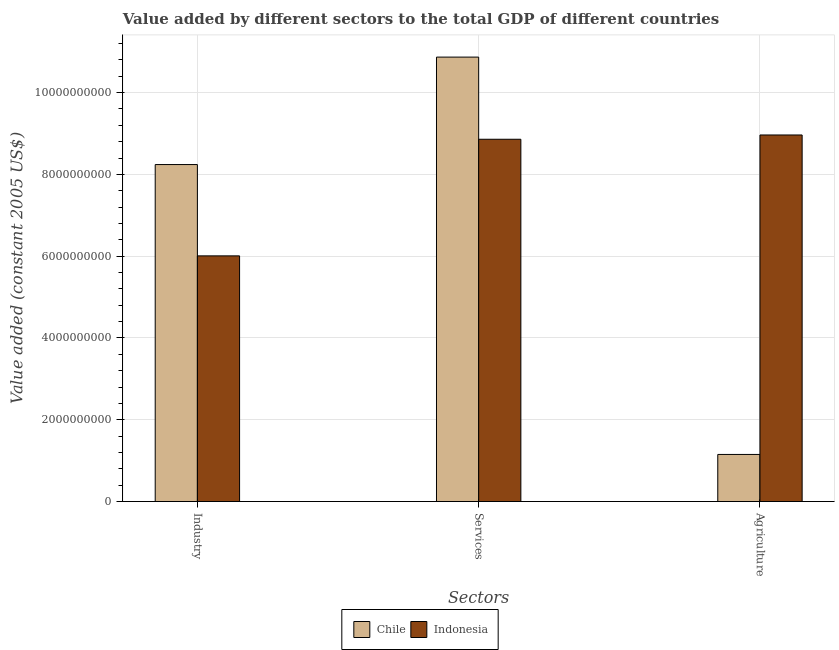How many different coloured bars are there?
Make the answer very short. 2. Are the number of bars per tick equal to the number of legend labels?
Ensure brevity in your answer.  Yes. Are the number of bars on each tick of the X-axis equal?
Provide a short and direct response. Yes. How many bars are there on the 1st tick from the left?
Your response must be concise. 2. How many bars are there on the 3rd tick from the right?
Your answer should be compact. 2. What is the label of the 2nd group of bars from the left?
Offer a very short reply. Services. What is the value added by agricultural sector in Indonesia?
Provide a succinct answer. 8.96e+09. Across all countries, what is the maximum value added by services?
Give a very brief answer. 1.09e+1. Across all countries, what is the minimum value added by agricultural sector?
Your response must be concise. 1.15e+09. In which country was the value added by industrial sector maximum?
Offer a terse response. Chile. In which country was the value added by services minimum?
Keep it short and to the point. Indonesia. What is the total value added by agricultural sector in the graph?
Provide a short and direct response. 1.01e+1. What is the difference between the value added by services in Chile and that in Indonesia?
Your answer should be compact. 2.01e+09. What is the difference between the value added by agricultural sector in Chile and the value added by services in Indonesia?
Give a very brief answer. -7.71e+09. What is the average value added by services per country?
Offer a terse response. 9.86e+09. What is the difference between the value added by agricultural sector and value added by industrial sector in Chile?
Give a very brief answer. -7.09e+09. What is the ratio of the value added by agricultural sector in Chile to that in Indonesia?
Ensure brevity in your answer.  0.13. Is the value added by services in Chile less than that in Indonesia?
Keep it short and to the point. No. Is the difference between the value added by agricultural sector in Indonesia and Chile greater than the difference between the value added by industrial sector in Indonesia and Chile?
Your answer should be compact. Yes. What is the difference between the highest and the second highest value added by industrial sector?
Provide a short and direct response. 2.23e+09. What is the difference between the highest and the lowest value added by services?
Offer a terse response. 2.01e+09. Is the sum of the value added by industrial sector in Chile and Indonesia greater than the maximum value added by services across all countries?
Provide a short and direct response. Yes. What does the 1st bar from the left in Agriculture represents?
Keep it short and to the point. Chile. How many bars are there?
Your answer should be compact. 6. Are all the bars in the graph horizontal?
Provide a succinct answer. No. How many countries are there in the graph?
Keep it short and to the point. 2. Does the graph contain grids?
Offer a very short reply. Yes. Where does the legend appear in the graph?
Your response must be concise. Bottom center. How are the legend labels stacked?
Offer a very short reply. Horizontal. What is the title of the graph?
Your answer should be very brief. Value added by different sectors to the total GDP of different countries. Does "Argentina" appear as one of the legend labels in the graph?
Your answer should be compact. No. What is the label or title of the X-axis?
Make the answer very short. Sectors. What is the label or title of the Y-axis?
Your answer should be very brief. Value added (constant 2005 US$). What is the Value added (constant 2005 US$) in Chile in Industry?
Make the answer very short. 8.24e+09. What is the Value added (constant 2005 US$) in Indonesia in Industry?
Ensure brevity in your answer.  6.01e+09. What is the Value added (constant 2005 US$) in Chile in Services?
Your answer should be very brief. 1.09e+1. What is the Value added (constant 2005 US$) in Indonesia in Services?
Offer a terse response. 8.86e+09. What is the Value added (constant 2005 US$) of Chile in Agriculture?
Your answer should be compact. 1.15e+09. What is the Value added (constant 2005 US$) of Indonesia in Agriculture?
Keep it short and to the point. 8.96e+09. Across all Sectors, what is the maximum Value added (constant 2005 US$) of Chile?
Provide a short and direct response. 1.09e+1. Across all Sectors, what is the maximum Value added (constant 2005 US$) of Indonesia?
Offer a very short reply. 8.96e+09. Across all Sectors, what is the minimum Value added (constant 2005 US$) of Chile?
Provide a succinct answer. 1.15e+09. Across all Sectors, what is the minimum Value added (constant 2005 US$) in Indonesia?
Your answer should be very brief. 6.01e+09. What is the total Value added (constant 2005 US$) of Chile in the graph?
Your response must be concise. 2.03e+1. What is the total Value added (constant 2005 US$) of Indonesia in the graph?
Offer a terse response. 2.38e+1. What is the difference between the Value added (constant 2005 US$) in Chile in Industry and that in Services?
Keep it short and to the point. -2.63e+09. What is the difference between the Value added (constant 2005 US$) of Indonesia in Industry and that in Services?
Your answer should be compact. -2.85e+09. What is the difference between the Value added (constant 2005 US$) in Chile in Industry and that in Agriculture?
Provide a succinct answer. 7.09e+09. What is the difference between the Value added (constant 2005 US$) of Indonesia in Industry and that in Agriculture?
Provide a short and direct response. -2.96e+09. What is the difference between the Value added (constant 2005 US$) of Chile in Services and that in Agriculture?
Keep it short and to the point. 9.72e+09. What is the difference between the Value added (constant 2005 US$) of Indonesia in Services and that in Agriculture?
Your response must be concise. -1.05e+08. What is the difference between the Value added (constant 2005 US$) in Chile in Industry and the Value added (constant 2005 US$) in Indonesia in Services?
Your answer should be compact. -6.19e+08. What is the difference between the Value added (constant 2005 US$) of Chile in Industry and the Value added (constant 2005 US$) of Indonesia in Agriculture?
Your answer should be compact. -7.23e+08. What is the difference between the Value added (constant 2005 US$) of Chile in Services and the Value added (constant 2005 US$) of Indonesia in Agriculture?
Make the answer very short. 1.90e+09. What is the average Value added (constant 2005 US$) in Chile per Sectors?
Make the answer very short. 6.75e+09. What is the average Value added (constant 2005 US$) in Indonesia per Sectors?
Offer a terse response. 7.94e+09. What is the difference between the Value added (constant 2005 US$) in Chile and Value added (constant 2005 US$) in Indonesia in Industry?
Provide a succinct answer. 2.23e+09. What is the difference between the Value added (constant 2005 US$) in Chile and Value added (constant 2005 US$) in Indonesia in Services?
Offer a terse response. 2.01e+09. What is the difference between the Value added (constant 2005 US$) of Chile and Value added (constant 2005 US$) of Indonesia in Agriculture?
Make the answer very short. -7.81e+09. What is the ratio of the Value added (constant 2005 US$) in Chile in Industry to that in Services?
Ensure brevity in your answer.  0.76. What is the ratio of the Value added (constant 2005 US$) of Indonesia in Industry to that in Services?
Give a very brief answer. 0.68. What is the ratio of the Value added (constant 2005 US$) of Chile in Industry to that in Agriculture?
Provide a succinct answer. 7.15. What is the ratio of the Value added (constant 2005 US$) in Indonesia in Industry to that in Agriculture?
Offer a terse response. 0.67. What is the ratio of the Value added (constant 2005 US$) of Chile in Services to that in Agriculture?
Your response must be concise. 9.43. What is the ratio of the Value added (constant 2005 US$) in Indonesia in Services to that in Agriculture?
Offer a very short reply. 0.99. What is the difference between the highest and the second highest Value added (constant 2005 US$) of Chile?
Offer a terse response. 2.63e+09. What is the difference between the highest and the second highest Value added (constant 2005 US$) of Indonesia?
Give a very brief answer. 1.05e+08. What is the difference between the highest and the lowest Value added (constant 2005 US$) in Chile?
Ensure brevity in your answer.  9.72e+09. What is the difference between the highest and the lowest Value added (constant 2005 US$) in Indonesia?
Offer a terse response. 2.96e+09. 